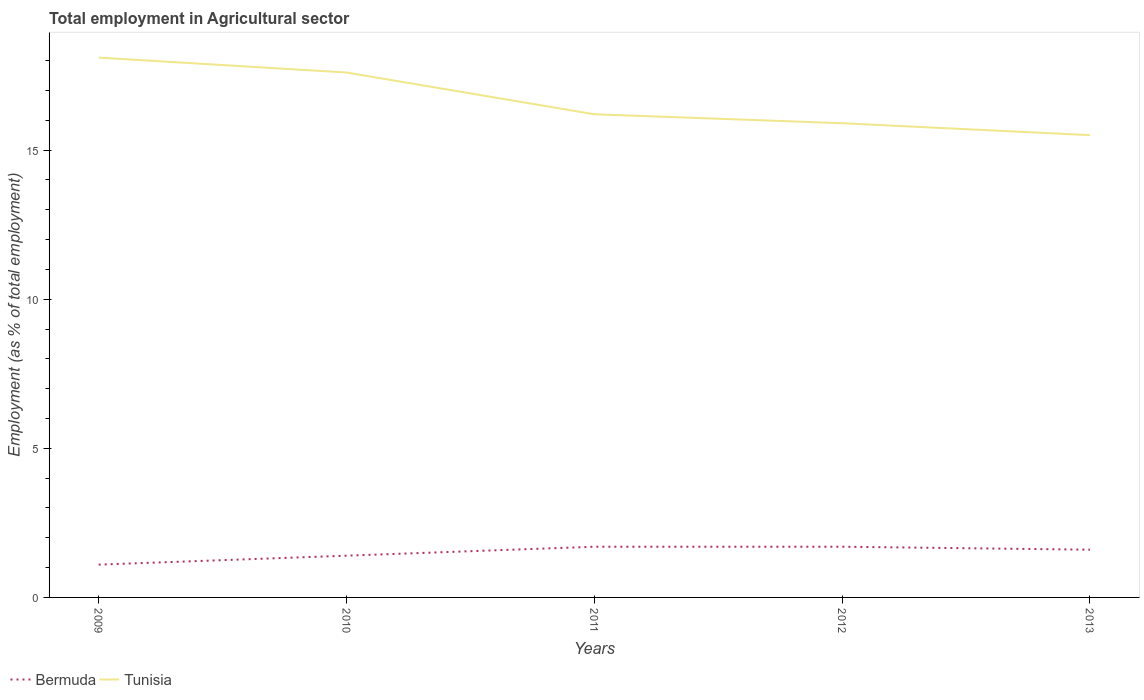How many different coloured lines are there?
Keep it short and to the point. 2. Does the line corresponding to Bermuda intersect with the line corresponding to Tunisia?
Provide a succinct answer. No. Is the number of lines equal to the number of legend labels?
Make the answer very short. Yes. Across all years, what is the maximum employment in agricultural sector in Bermuda?
Keep it short and to the point. 1.1. What is the total employment in agricultural sector in Bermuda in the graph?
Your answer should be very brief. -0.6. What is the difference between the highest and the second highest employment in agricultural sector in Tunisia?
Offer a terse response. 2.6. How many years are there in the graph?
Offer a very short reply. 5. What is the difference between two consecutive major ticks on the Y-axis?
Provide a succinct answer. 5. Are the values on the major ticks of Y-axis written in scientific E-notation?
Provide a short and direct response. No. Does the graph contain grids?
Ensure brevity in your answer.  No. What is the title of the graph?
Give a very brief answer. Total employment in Agricultural sector. What is the label or title of the Y-axis?
Provide a succinct answer. Employment (as % of total employment). What is the Employment (as % of total employment) in Bermuda in 2009?
Your response must be concise. 1.1. What is the Employment (as % of total employment) in Tunisia in 2009?
Make the answer very short. 18.1. What is the Employment (as % of total employment) in Bermuda in 2010?
Make the answer very short. 1.4. What is the Employment (as % of total employment) in Tunisia in 2010?
Provide a short and direct response. 17.6. What is the Employment (as % of total employment) of Bermuda in 2011?
Provide a short and direct response. 1.7. What is the Employment (as % of total employment) in Tunisia in 2011?
Make the answer very short. 16.2. What is the Employment (as % of total employment) of Bermuda in 2012?
Provide a succinct answer. 1.7. What is the Employment (as % of total employment) in Tunisia in 2012?
Make the answer very short. 15.9. What is the Employment (as % of total employment) of Bermuda in 2013?
Give a very brief answer. 1.6. What is the Employment (as % of total employment) in Tunisia in 2013?
Ensure brevity in your answer.  15.5. Across all years, what is the maximum Employment (as % of total employment) of Bermuda?
Keep it short and to the point. 1.7. Across all years, what is the maximum Employment (as % of total employment) in Tunisia?
Ensure brevity in your answer.  18.1. Across all years, what is the minimum Employment (as % of total employment) of Bermuda?
Offer a very short reply. 1.1. What is the total Employment (as % of total employment) in Bermuda in the graph?
Provide a succinct answer. 7.5. What is the total Employment (as % of total employment) in Tunisia in the graph?
Your answer should be very brief. 83.3. What is the difference between the Employment (as % of total employment) in Bermuda in 2009 and that in 2013?
Ensure brevity in your answer.  -0.5. What is the difference between the Employment (as % of total employment) of Bermuda in 2010 and that in 2011?
Your response must be concise. -0.3. What is the difference between the Employment (as % of total employment) of Tunisia in 2010 and that in 2011?
Ensure brevity in your answer.  1.4. What is the difference between the Employment (as % of total employment) of Bermuda in 2010 and that in 2012?
Your response must be concise. -0.3. What is the difference between the Employment (as % of total employment) in Tunisia in 2010 and that in 2012?
Make the answer very short. 1.7. What is the difference between the Employment (as % of total employment) in Tunisia in 2010 and that in 2013?
Your answer should be compact. 2.1. What is the difference between the Employment (as % of total employment) in Bermuda in 2011 and that in 2012?
Provide a short and direct response. 0. What is the difference between the Employment (as % of total employment) of Bermuda in 2011 and that in 2013?
Provide a short and direct response. 0.1. What is the difference between the Employment (as % of total employment) in Tunisia in 2011 and that in 2013?
Provide a succinct answer. 0.7. What is the difference between the Employment (as % of total employment) of Bermuda in 2009 and the Employment (as % of total employment) of Tunisia in 2010?
Provide a short and direct response. -16.5. What is the difference between the Employment (as % of total employment) in Bermuda in 2009 and the Employment (as % of total employment) in Tunisia in 2011?
Offer a terse response. -15.1. What is the difference between the Employment (as % of total employment) in Bermuda in 2009 and the Employment (as % of total employment) in Tunisia in 2012?
Your answer should be compact. -14.8. What is the difference between the Employment (as % of total employment) in Bermuda in 2009 and the Employment (as % of total employment) in Tunisia in 2013?
Your answer should be very brief. -14.4. What is the difference between the Employment (as % of total employment) in Bermuda in 2010 and the Employment (as % of total employment) in Tunisia in 2011?
Your answer should be compact. -14.8. What is the difference between the Employment (as % of total employment) in Bermuda in 2010 and the Employment (as % of total employment) in Tunisia in 2012?
Offer a terse response. -14.5. What is the difference between the Employment (as % of total employment) of Bermuda in 2010 and the Employment (as % of total employment) of Tunisia in 2013?
Your response must be concise. -14.1. What is the difference between the Employment (as % of total employment) in Bermuda in 2012 and the Employment (as % of total employment) in Tunisia in 2013?
Provide a short and direct response. -13.8. What is the average Employment (as % of total employment) of Bermuda per year?
Give a very brief answer. 1.5. What is the average Employment (as % of total employment) of Tunisia per year?
Offer a very short reply. 16.66. In the year 2010, what is the difference between the Employment (as % of total employment) of Bermuda and Employment (as % of total employment) of Tunisia?
Your answer should be very brief. -16.2. In the year 2012, what is the difference between the Employment (as % of total employment) in Bermuda and Employment (as % of total employment) in Tunisia?
Offer a very short reply. -14.2. What is the ratio of the Employment (as % of total employment) in Bermuda in 2009 to that in 2010?
Ensure brevity in your answer.  0.79. What is the ratio of the Employment (as % of total employment) of Tunisia in 2009 to that in 2010?
Give a very brief answer. 1.03. What is the ratio of the Employment (as % of total employment) of Bermuda in 2009 to that in 2011?
Ensure brevity in your answer.  0.65. What is the ratio of the Employment (as % of total employment) in Tunisia in 2009 to that in 2011?
Provide a succinct answer. 1.12. What is the ratio of the Employment (as % of total employment) in Bermuda in 2009 to that in 2012?
Offer a very short reply. 0.65. What is the ratio of the Employment (as % of total employment) in Tunisia in 2009 to that in 2012?
Your response must be concise. 1.14. What is the ratio of the Employment (as % of total employment) of Bermuda in 2009 to that in 2013?
Your answer should be compact. 0.69. What is the ratio of the Employment (as % of total employment) of Tunisia in 2009 to that in 2013?
Provide a succinct answer. 1.17. What is the ratio of the Employment (as % of total employment) of Bermuda in 2010 to that in 2011?
Your answer should be compact. 0.82. What is the ratio of the Employment (as % of total employment) in Tunisia in 2010 to that in 2011?
Offer a very short reply. 1.09. What is the ratio of the Employment (as % of total employment) in Bermuda in 2010 to that in 2012?
Ensure brevity in your answer.  0.82. What is the ratio of the Employment (as % of total employment) in Tunisia in 2010 to that in 2012?
Your answer should be compact. 1.11. What is the ratio of the Employment (as % of total employment) of Tunisia in 2010 to that in 2013?
Your response must be concise. 1.14. What is the ratio of the Employment (as % of total employment) in Bermuda in 2011 to that in 2012?
Give a very brief answer. 1. What is the ratio of the Employment (as % of total employment) in Tunisia in 2011 to that in 2012?
Provide a short and direct response. 1.02. What is the ratio of the Employment (as % of total employment) of Tunisia in 2011 to that in 2013?
Keep it short and to the point. 1.05. What is the ratio of the Employment (as % of total employment) in Tunisia in 2012 to that in 2013?
Give a very brief answer. 1.03. What is the difference between the highest and the lowest Employment (as % of total employment) of Bermuda?
Offer a very short reply. 0.6. 